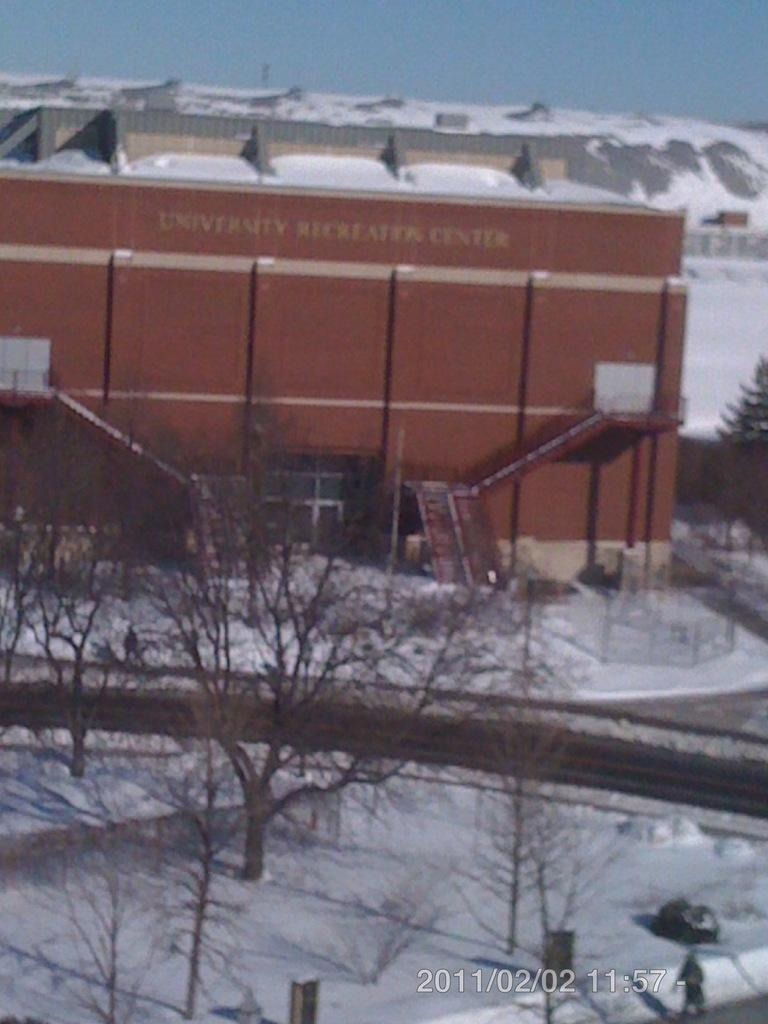What type of natural elements can be seen in the image? There are trees in the image. What type of man-made structures are present in the image? There are buildings in the image. What weather condition is depicted in the image? There is snow visible in the image. Where can text be found in the image? There is text in the bottom right-hand corner of the image. What type of territory is being mapped out in the image? There is no map or territory present in the image; it features trees, buildings, snow, and text. Can you see any sails in the image? There are no sails visible in the image. 